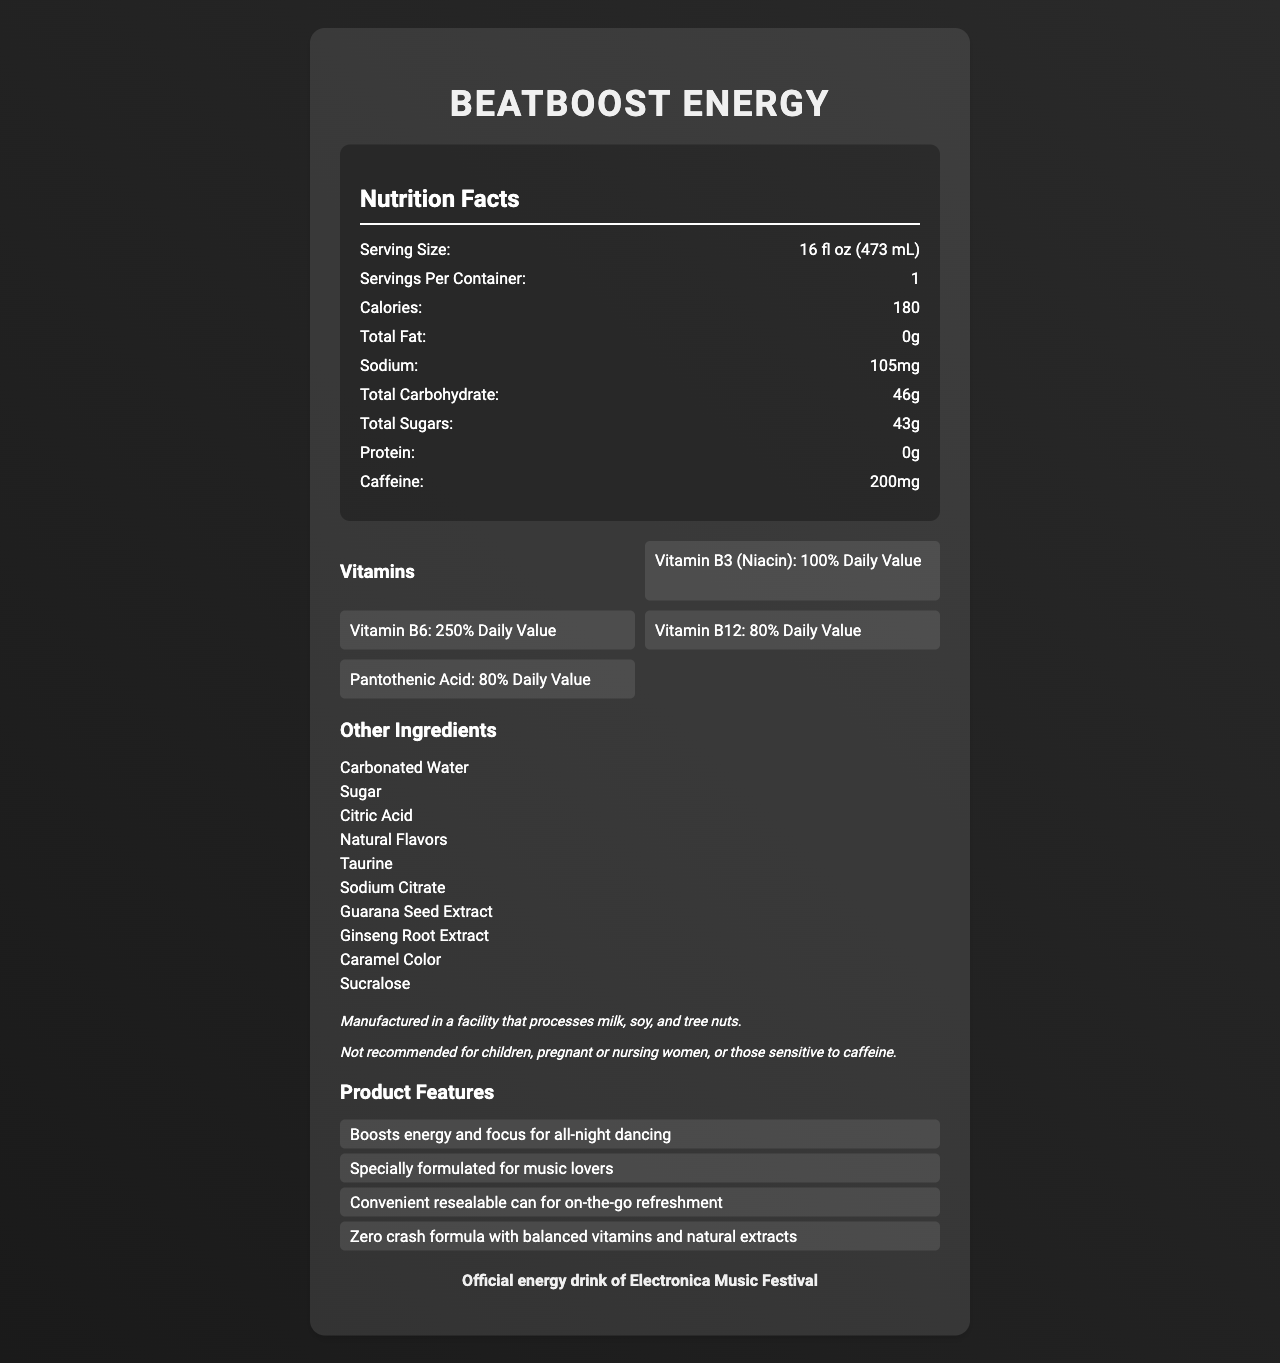what is the serving size? The serving size is specified as "16 fl oz (473 mL)" in the nutrition facts section.
Answer: 16 fl oz (473 mL) how many calories are in one serving? The document lists 180 calories in one serving under the nutrition facts.
Answer: 180 how much caffeine is in one serving? The caffeine content is listed as "200mg" in the nutrition facts section.
Answer: 200mg what vitamins are included and in what amounts? The vitamins and their amounts are listed under the vitamins section with specific daily value percentages.
Answer: Vitamin B3 (Niacin): 100% Daily Value, Vitamin B6: 250% Daily Value, Vitamin B12: 80% Daily Value, Pantothenic Acid: 80% Daily Value how many grams of total sugars are present in one serving? The total sugars content is listed as "43g" in the nutrition facts section.
Answer: 43g what are the other ingredients included in the product? The other ingredients are listed in the section titled "Other Ingredients".
Answer: Carbonated Water, Sugar, Citric Acid, Natural Flavors, Taurine, Sodium Citrate, Guarana Seed Extract, Ginseng Root Extract, Caramel Color, Sucralose how much sodium is in one serving? A. 105mg B. 150mg C. 50mg D. 30mg The sodium content is listed as "105mg" in the nutrition facts section.
Answer: A. 105mg which vitamin has the highest daily value percentage? I. Vitamin B3 II. Vitamin B6 III. Vitamin B12 IV. Pantothenic Acid Vitamin B6 has the highest daily value percentage at 250%, which is higher than the other listed vitamins.
Answer: II. Vitamin B6 what is the main marketing partnership mentioned in the document? The document mentions that BeatBoost Energy is the "Official energy drink of Electronica Music Festival".
Answer: Official energy drink of Electronica Music Festival what allergens does the product potentially contain? The allergen information section states that the product is manufactured in a facility that processes milk, soy, and tree nuts.
Answer: milk, soy, and tree nuts is the product recommended for children or pregnant women? The disclaimer states it is not recommended for children, pregnant or nursing women, or those sensitive to caffeine.
Answer: No describe the main claims made about this energy drink. The marketing claims section highlights that BeatBoost Energy is designed to enhance energy and focus, is convenient for music lovers, and offers balanced vitamins and natural extracts to avoid a crash.
Answer: BeatBoost Energy claims to boost energy and focus for all-night dancing, is specially formulated for music lovers, comes in a convenient resealable can for on-the-go refreshment, and has a zero crash formula with balanced vitamins and natural extracts. does the document provide information on the glass recycling process? The document mentions the product is recyclable but does not provide specific details about the recycling process.
Answer: Not enough information 